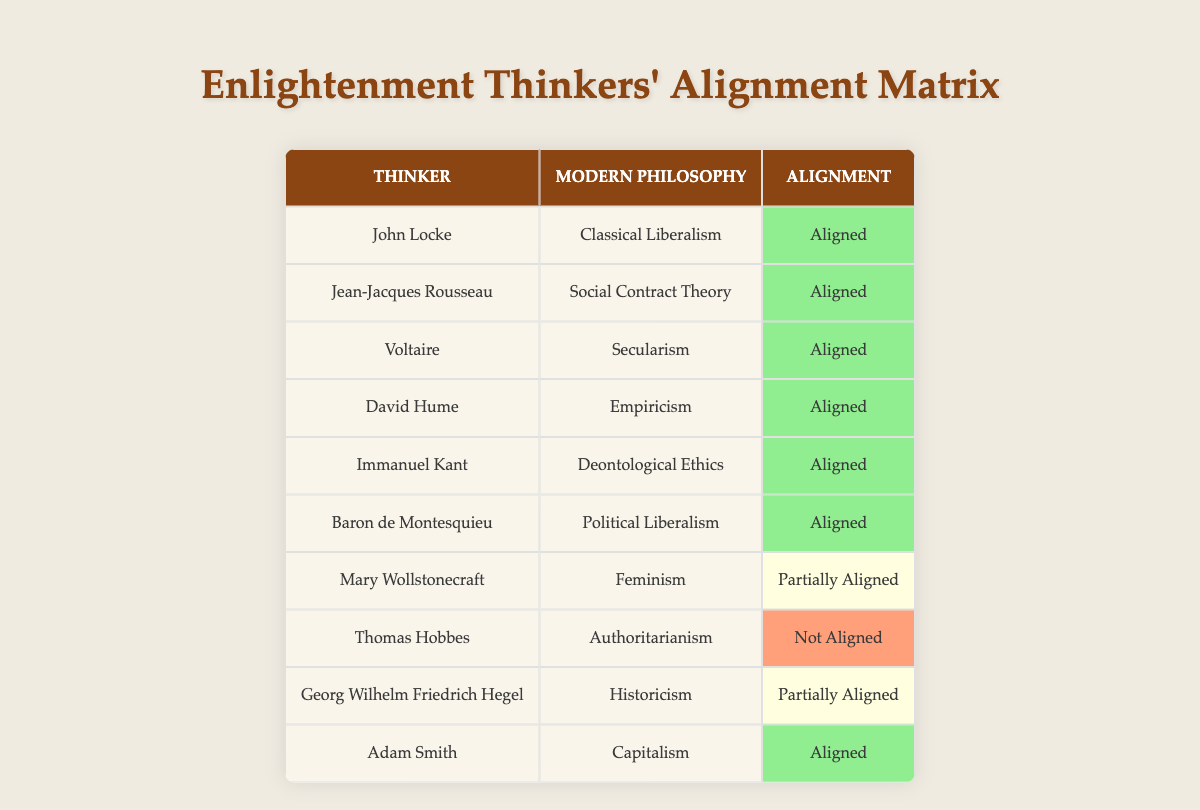What is the modern philosophy associated with Immanuel Kant? Immanuel Kant's modern philosophy, as listed in the table, is Deontological Ethics.
Answer: Deontological Ethics Which Enlightenment thinker is aligned with Feminism? The thinker aligned with Feminism is Mary Wollstonecraft, as noted in the alignment column.
Answer: Mary Wollstonecraft How many thinkers are aligned with Capitalism? Referring to the table, only one thinker, Adam Smith, is noted as aligned with Capitalism.
Answer: One Is Thomas Hobbes aligned with Social Contract Theory? According to the table, Thomas Hobbes is aligned with Authoritarianism, not Social Contract Theory, therefore the statement is false.
Answer: No Which thinkers have a partial alignment with modern philosophies? The thinkers with partial alignment, as per the table, are Mary Wollstonecraft and Georg Wilhelm Friedrich Hegel.
Answer: Mary Wollstonecraft, Georg Wilhelm Friedrich Hegel What percentage of the thinkers are fully aligned with their modern philosophies? Out of a total of 10 thinkers, 7 are fully aligned. Thus, the percentage is (7/10) * 100 = 70%.
Answer: 70% Who is the thinker associated with Authoritarianism? The thinker associated with Authoritarianism, as indicated in the table, is Thomas Hobbes.
Answer: Thomas Hobbes Is there any thinker who is not aligned with any modern philosophy? The table shows Thomas Hobbes is not aligned with any modern philosophy, making the answer yes.
Answer: Yes What is the alignment status of Jean-Jacques Rousseau? The table indicates that Jean-Jacques Rousseau is aligned with Social Contract Theory, suggesting he has full alignment.
Answer: Aligned 